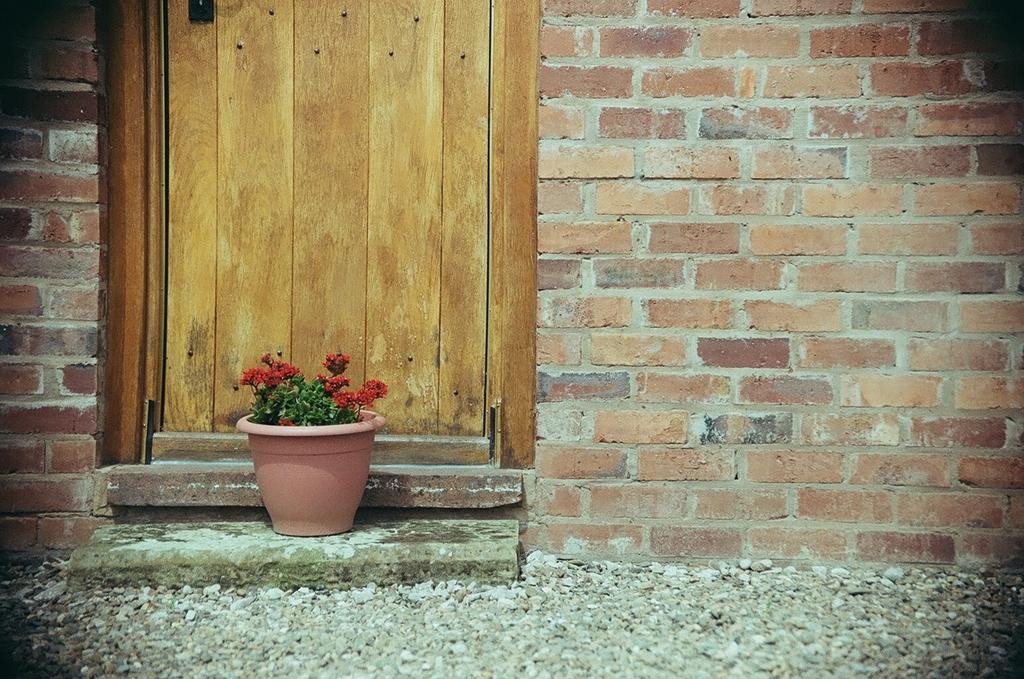What is one of the main structures in the image? There is a door in the image. What type of material is used for the walls in the image? There are brick walls in the image. What type of plant can be seen in the image? There is a flower plant with a pot in the image. What type of ground surface is visible in the image? There are stones at the bottom of the image. What color is the object at the top of the image? There is a black color object at the top of the image. How many people are in the group that is pushing the door in the image? There is no group of people pushing the door in the image; it is a still image with no visible movement or action. What type of toothbrush is used to clean the black color object at the top of the image? There is no toothbrush present in the image, and the black color object at the top of the image does not require cleaning. 